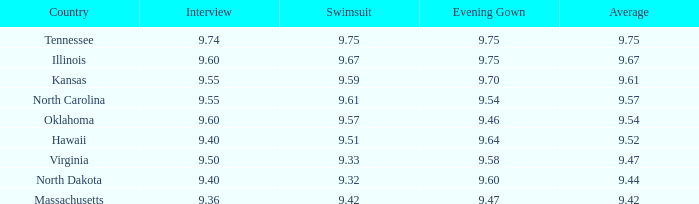What is the swimsuit score when the interview was 9.74? 9.75. 